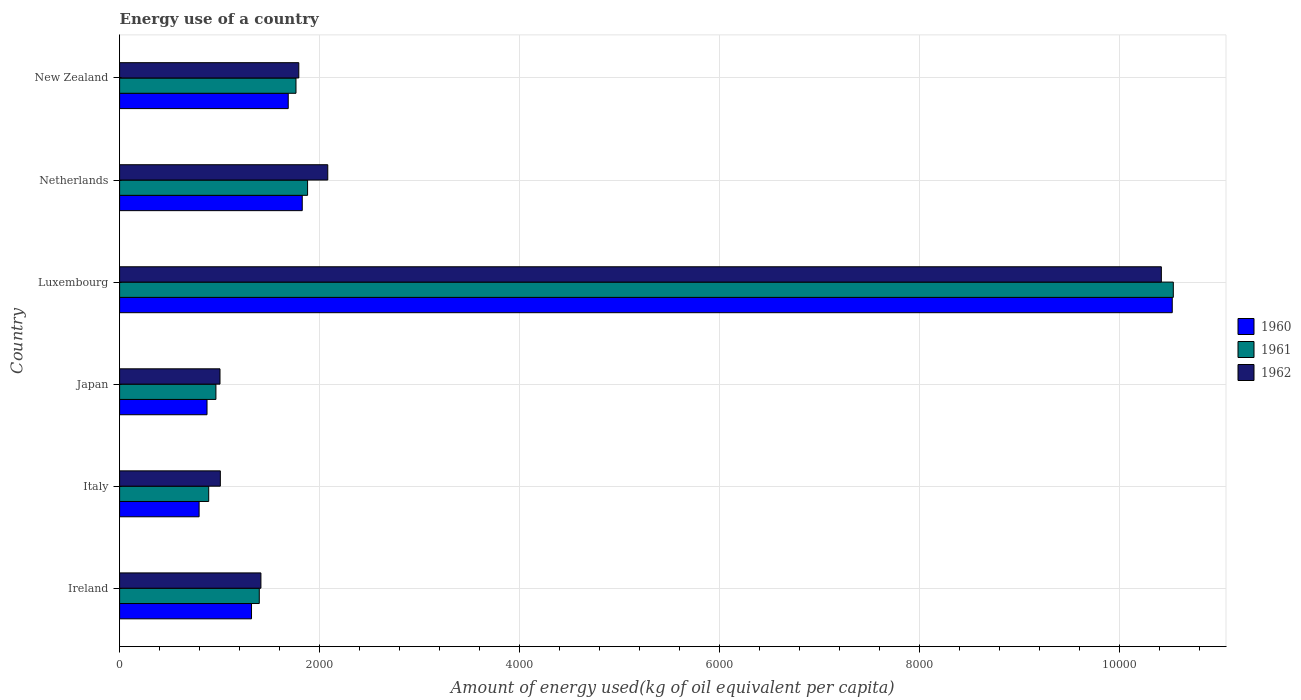Are the number of bars on each tick of the Y-axis equal?
Offer a very short reply. Yes. What is the label of the 3rd group of bars from the top?
Offer a terse response. Luxembourg. In how many cases, is the number of bars for a given country not equal to the number of legend labels?
Your answer should be compact. 0. What is the amount of energy used in in 1962 in Japan?
Keep it short and to the point. 1003.75. Across all countries, what is the maximum amount of energy used in in 1962?
Offer a very short reply. 1.04e+04. Across all countries, what is the minimum amount of energy used in in 1961?
Ensure brevity in your answer.  890.69. In which country was the amount of energy used in in 1960 maximum?
Make the answer very short. Luxembourg. What is the total amount of energy used in in 1961 in the graph?
Offer a terse response. 1.74e+04. What is the difference between the amount of energy used in in 1961 in Luxembourg and that in Netherlands?
Your answer should be very brief. 8654.87. What is the difference between the amount of energy used in in 1961 in Luxembourg and the amount of energy used in in 1960 in Japan?
Provide a succinct answer. 9660.11. What is the average amount of energy used in in 1960 per country?
Offer a terse response. 2837.11. What is the difference between the amount of energy used in in 1962 and amount of energy used in in 1961 in Ireland?
Your answer should be very brief. 16.26. What is the ratio of the amount of energy used in in 1960 in Ireland to that in New Zealand?
Ensure brevity in your answer.  0.78. Is the amount of energy used in in 1960 in Netherlands less than that in New Zealand?
Provide a short and direct response. No. Is the difference between the amount of energy used in in 1962 in Italy and Netherlands greater than the difference between the amount of energy used in in 1961 in Italy and Netherlands?
Offer a very short reply. No. What is the difference between the highest and the second highest amount of energy used in in 1960?
Offer a very short reply. 8697.47. What is the difference between the highest and the lowest amount of energy used in in 1961?
Your answer should be very brief. 9643.33. In how many countries, is the amount of energy used in in 1960 greater than the average amount of energy used in in 1960 taken over all countries?
Your answer should be very brief. 1. What does the 3rd bar from the top in Netherlands represents?
Keep it short and to the point. 1960. What does the 1st bar from the bottom in New Zealand represents?
Your answer should be compact. 1960. How many bars are there?
Give a very brief answer. 18. Are all the bars in the graph horizontal?
Provide a short and direct response. Yes. Are the values on the major ticks of X-axis written in scientific E-notation?
Your response must be concise. No. How many legend labels are there?
Provide a succinct answer. 3. What is the title of the graph?
Provide a short and direct response. Energy use of a country. What is the label or title of the X-axis?
Your answer should be very brief. Amount of energy used(kg of oil equivalent per capita). What is the label or title of the Y-axis?
Your answer should be very brief. Country. What is the Amount of energy used(kg of oil equivalent per capita) of 1960 in Ireland?
Provide a short and direct response. 1318.81. What is the Amount of energy used(kg of oil equivalent per capita) in 1961 in Ireland?
Your response must be concise. 1396.47. What is the Amount of energy used(kg of oil equivalent per capita) in 1962 in Ireland?
Ensure brevity in your answer.  1412.73. What is the Amount of energy used(kg of oil equivalent per capita) in 1960 in Italy?
Offer a very short reply. 794.82. What is the Amount of energy used(kg of oil equivalent per capita) in 1961 in Italy?
Offer a very short reply. 890.69. What is the Amount of energy used(kg of oil equivalent per capita) of 1962 in Italy?
Your answer should be compact. 1007.05. What is the Amount of energy used(kg of oil equivalent per capita) of 1960 in Japan?
Give a very brief answer. 873.91. What is the Amount of energy used(kg of oil equivalent per capita) of 1961 in Japan?
Provide a succinct answer. 962.91. What is the Amount of energy used(kg of oil equivalent per capita) in 1962 in Japan?
Make the answer very short. 1003.75. What is the Amount of energy used(kg of oil equivalent per capita) in 1960 in Luxembourg?
Your response must be concise. 1.05e+04. What is the Amount of energy used(kg of oil equivalent per capita) in 1961 in Luxembourg?
Give a very brief answer. 1.05e+04. What is the Amount of energy used(kg of oil equivalent per capita) of 1962 in Luxembourg?
Your response must be concise. 1.04e+04. What is the Amount of energy used(kg of oil equivalent per capita) of 1960 in Netherlands?
Give a very brief answer. 1825.93. What is the Amount of energy used(kg of oil equivalent per capita) in 1961 in Netherlands?
Offer a very short reply. 1879.15. What is the Amount of energy used(kg of oil equivalent per capita) in 1962 in Netherlands?
Give a very brief answer. 2081.01. What is the Amount of energy used(kg of oil equivalent per capita) in 1960 in New Zealand?
Make the answer very short. 1685.79. What is the Amount of energy used(kg of oil equivalent per capita) of 1961 in New Zealand?
Give a very brief answer. 1763.26. What is the Amount of energy used(kg of oil equivalent per capita) in 1962 in New Zealand?
Your answer should be very brief. 1791.46. Across all countries, what is the maximum Amount of energy used(kg of oil equivalent per capita) in 1960?
Ensure brevity in your answer.  1.05e+04. Across all countries, what is the maximum Amount of energy used(kg of oil equivalent per capita) in 1961?
Provide a short and direct response. 1.05e+04. Across all countries, what is the maximum Amount of energy used(kg of oil equivalent per capita) of 1962?
Provide a short and direct response. 1.04e+04. Across all countries, what is the minimum Amount of energy used(kg of oil equivalent per capita) in 1960?
Give a very brief answer. 794.82. Across all countries, what is the minimum Amount of energy used(kg of oil equivalent per capita) of 1961?
Your response must be concise. 890.69. Across all countries, what is the minimum Amount of energy used(kg of oil equivalent per capita) of 1962?
Make the answer very short. 1003.75. What is the total Amount of energy used(kg of oil equivalent per capita) of 1960 in the graph?
Give a very brief answer. 1.70e+04. What is the total Amount of energy used(kg of oil equivalent per capita) of 1961 in the graph?
Your response must be concise. 1.74e+04. What is the total Amount of energy used(kg of oil equivalent per capita) of 1962 in the graph?
Make the answer very short. 1.77e+04. What is the difference between the Amount of energy used(kg of oil equivalent per capita) of 1960 in Ireland and that in Italy?
Ensure brevity in your answer.  524. What is the difference between the Amount of energy used(kg of oil equivalent per capita) in 1961 in Ireland and that in Italy?
Offer a very short reply. 505.78. What is the difference between the Amount of energy used(kg of oil equivalent per capita) in 1962 in Ireland and that in Italy?
Keep it short and to the point. 405.68. What is the difference between the Amount of energy used(kg of oil equivalent per capita) of 1960 in Ireland and that in Japan?
Offer a very short reply. 444.9. What is the difference between the Amount of energy used(kg of oil equivalent per capita) of 1961 in Ireland and that in Japan?
Make the answer very short. 433.56. What is the difference between the Amount of energy used(kg of oil equivalent per capita) in 1962 in Ireland and that in Japan?
Your answer should be very brief. 408.98. What is the difference between the Amount of energy used(kg of oil equivalent per capita) in 1960 in Ireland and that in Luxembourg?
Offer a terse response. -9204.59. What is the difference between the Amount of energy used(kg of oil equivalent per capita) of 1961 in Ireland and that in Luxembourg?
Give a very brief answer. -9137.55. What is the difference between the Amount of energy used(kg of oil equivalent per capita) in 1962 in Ireland and that in Luxembourg?
Keep it short and to the point. -9001.81. What is the difference between the Amount of energy used(kg of oil equivalent per capita) of 1960 in Ireland and that in Netherlands?
Your response must be concise. -507.12. What is the difference between the Amount of energy used(kg of oil equivalent per capita) of 1961 in Ireland and that in Netherlands?
Offer a terse response. -482.68. What is the difference between the Amount of energy used(kg of oil equivalent per capita) in 1962 in Ireland and that in Netherlands?
Keep it short and to the point. -668.28. What is the difference between the Amount of energy used(kg of oil equivalent per capita) in 1960 in Ireland and that in New Zealand?
Offer a very short reply. -366.98. What is the difference between the Amount of energy used(kg of oil equivalent per capita) in 1961 in Ireland and that in New Zealand?
Provide a short and direct response. -366.79. What is the difference between the Amount of energy used(kg of oil equivalent per capita) of 1962 in Ireland and that in New Zealand?
Keep it short and to the point. -378.73. What is the difference between the Amount of energy used(kg of oil equivalent per capita) of 1960 in Italy and that in Japan?
Provide a short and direct response. -79.09. What is the difference between the Amount of energy used(kg of oil equivalent per capita) in 1961 in Italy and that in Japan?
Ensure brevity in your answer.  -72.22. What is the difference between the Amount of energy used(kg of oil equivalent per capita) of 1962 in Italy and that in Japan?
Your answer should be very brief. 3.3. What is the difference between the Amount of energy used(kg of oil equivalent per capita) in 1960 in Italy and that in Luxembourg?
Your answer should be compact. -9728.59. What is the difference between the Amount of energy used(kg of oil equivalent per capita) in 1961 in Italy and that in Luxembourg?
Make the answer very short. -9643.33. What is the difference between the Amount of energy used(kg of oil equivalent per capita) in 1962 in Italy and that in Luxembourg?
Offer a terse response. -9407.49. What is the difference between the Amount of energy used(kg of oil equivalent per capita) of 1960 in Italy and that in Netherlands?
Your answer should be very brief. -1031.12. What is the difference between the Amount of energy used(kg of oil equivalent per capita) of 1961 in Italy and that in Netherlands?
Offer a terse response. -988.46. What is the difference between the Amount of energy used(kg of oil equivalent per capita) in 1962 in Italy and that in Netherlands?
Provide a succinct answer. -1073.96. What is the difference between the Amount of energy used(kg of oil equivalent per capita) of 1960 in Italy and that in New Zealand?
Offer a very short reply. -890.97. What is the difference between the Amount of energy used(kg of oil equivalent per capita) in 1961 in Italy and that in New Zealand?
Offer a terse response. -872.57. What is the difference between the Amount of energy used(kg of oil equivalent per capita) of 1962 in Italy and that in New Zealand?
Offer a terse response. -784.41. What is the difference between the Amount of energy used(kg of oil equivalent per capita) of 1960 in Japan and that in Luxembourg?
Your answer should be very brief. -9649.5. What is the difference between the Amount of energy used(kg of oil equivalent per capita) of 1961 in Japan and that in Luxembourg?
Ensure brevity in your answer.  -9571.11. What is the difference between the Amount of energy used(kg of oil equivalent per capita) in 1962 in Japan and that in Luxembourg?
Keep it short and to the point. -9410.79. What is the difference between the Amount of energy used(kg of oil equivalent per capita) of 1960 in Japan and that in Netherlands?
Make the answer very short. -952.02. What is the difference between the Amount of energy used(kg of oil equivalent per capita) in 1961 in Japan and that in Netherlands?
Your response must be concise. -916.24. What is the difference between the Amount of energy used(kg of oil equivalent per capita) in 1962 in Japan and that in Netherlands?
Your answer should be very brief. -1077.26. What is the difference between the Amount of energy used(kg of oil equivalent per capita) of 1960 in Japan and that in New Zealand?
Offer a terse response. -811.88. What is the difference between the Amount of energy used(kg of oil equivalent per capita) in 1961 in Japan and that in New Zealand?
Provide a short and direct response. -800.35. What is the difference between the Amount of energy used(kg of oil equivalent per capita) of 1962 in Japan and that in New Zealand?
Offer a terse response. -787.71. What is the difference between the Amount of energy used(kg of oil equivalent per capita) of 1960 in Luxembourg and that in Netherlands?
Your response must be concise. 8697.47. What is the difference between the Amount of energy used(kg of oil equivalent per capita) in 1961 in Luxembourg and that in Netherlands?
Keep it short and to the point. 8654.87. What is the difference between the Amount of energy used(kg of oil equivalent per capita) of 1962 in Luxembourg and that in Netherlands?
Make the answer very short. 8333.53. What is the difference between the Amount of energy used(kg of oil equivalent per capita) of 1960 in Luxembourg and that in New Zealand?
Your answer should be very brief. 8837.62. What is the difference between the Amount of energy used(kg of oil equivalent per capita) in 1961 in Luxembourg and that in New Zealand?
Make the answer very short. 8770.76. What is the difference between the Amount of energy used(kg of oil equivalent per capita) in 1962 in Luxembourg and that in New Zealand?
Keep it short and to the point. 8623.08. What is the difference between the Amount of energy used(kg of oil equivalent per capita) of 1960 in Netherlands and that in New Zealand?
Your answer should be very brief. 140.15. What is the difference between the Amount of energy used(kg of oil equivalent per capita) in 1961 in Netherlands and that in New Zealand?
Offer a terse response. 115.89. What is the difference between the Amount of energy used(kg of oil equivalent per capita) of 1962 in Netherlands and that in New Zealand?
Offer a terse response. 289.55. What is the difference between the Amount of energy used(kg of oil equivalent per capita) in 1960 in Ireland and the Amount of energy used(kg of oil equivalent per capita) in 1961 in Italy?
Give a very brief answer. 428.12. What is the difference between the Amount of energy used(kg of oil equivalent per capita) of 1960 in Ireland and the Amount of energy used(kg of oil equivalent per capita) of 1962 in Italy?
Your response must be concise. 311.76. What is the difference between the Amount of energy used(kg of oil equivalent per capita) in 1961 in Ireland and the Amount of energy used(kg of oil equivalent per capita) in 1962 in Italy?
Your response must be concise. 389.42. What is the difference between the Amount of energy used(kg of oil equivalent per capita) in 1960 in Ireland and the Amount of energy used(kg of oil equivalent per capita) in 1961 in Japan?
Your answer should be compact. 355.91. What is the difference between the Amount of energy used(kg of oil equivalent per capita) in 1960 in Ireland and the Amount of energy used(kg of oil equivalent per capita) in 1962 in Japan?
Make the answer very short. 315.06. What is the difference between the Amount of energy used(kg of oil equivalent per capita) in 1961 in Ireland and the Amount of energy used(kg of oil equivalent per capita) in 1962 in Japan?
Offer a terse response. 392.71. What is the difference between the Amount of energy used(kg of oil equivalent per capita) of 1960 in Ireland and the Amount of energy used(kg of oil equivalent per capita) of 1961 in Luxembourg?
Make the answer very short. -9215.21. What is the difference between the Amount of energy used(kg of oil equivalent per capita) of 1960 in Ireland and the Amount of energy used(kg of oil equivalent per capita) of 1962 in Luxembourg?
Offer a very short reply. -9095.73. What is the difference between the Amount of energy used(kg of oil equivalent per capita) in 1961 in Ireland and the Amount of energy used(kg of oil equivalent per capita) in 1962 in Luxembourg?
Your answer should be very brief. -9018.07. What is the difference between the Amount of energy used(kg of oil equivalent per capita) of 1960 in Ireland and the Amount of energy used(kg of oil equivalent per capita) of 1961 in Netherlands?
Your answer should be compact. -560.34. What is the difference between the Amount of energy used(kg of oil equivalent per capita) in 1960 in Ireland and the Amount of energy used(kg of oil equivalent per capita) in 1962 in Netherlands?
Offer a very short reply. -762.2. What is the difference between the Amount of energy used(kg of oil equivalent per capita) in 1961 in Ireland and the Amount of energy used(kg of oil equivalent per capita) in 1962 in Netherlands?
Offer a very short reply. -684.55. What is the difference between the Amount of energy used(kg of oil equivalent per capita) of 1960 in Ireland and the Amount of energy used(kg of oil equivalent per capita) of 1961 in New Zealand?
Provide a short and direct response. -444.45. What is the difference between the Amount of energy used(kg of oil equivalent per capita) in 1960 in Ireland and the Amount of energy used(kg of oil equivalent per capita) in 1962 in New Zealand?
Your answer should be compact. -472.65. What is the difference between the Amount of energy used(kg of oil equivalent per capita) of 1961 in Ireland and the Amount of energy used(kg of oil equivalent per capita) of 1962 in New Zealand?
Give a very brief answer. -395. What is the difference between the Amount of energy used(kg of oil equivalent per capita) in 1960 in Italy and the Amount of energy used(kg of oil equivalent per capita) in 1961 in Japan?
Offer a very short reply. -168.09. What is the difference between the Amount of energy used(kg of oil equivalent per capita) in 1960 in Italy and the Amount of energy used(kg of oil equivalent per capita) in 1962 in Japan?
Make the answer very short. -208.94. What is the difference between the Amount of energy used(kg of oil equivalent per capita) in 1961 in Italy and the Amount of energy used(kg of oil equivalent per capita) in 1962 in Japan?
Your answer should be compact. -113.06. What is the difference between the Amount of energy used(kg of oil equivalent per capita) of 1960 in Italy and the Amount of energy used(kg of oil equivalent per capita) of 1961 in Luxembourg?
Ensure brevity in your answer.  -9739.2. What is the difference between the Amount of energy used(kg of oil equivalent per capita) of 1960 in Italy and the Amount of energy used(kg of oil equivalent per capita) of 1962 in Luxembourg?
Offer a terse response. -9619.72. What is the difference between the Amount of energy used(kg of oil equivalent per capita) of 1961 in Italy and the Amount of energy used(kg of oil equivalent per capita) of 1962 in Luxembourg?
Your answer should be compact. -9523.85. What is the difference between the Amount of energy used(kg of oil equivalent per capita) in 1960 in Italy and the Amount of energy used(kg of oil equivalent per capita) in 1961 in Netherlands?
Make the answer very short. -1084.33. What is the difference between the Amount of energy used(kg of oil equivalent per capita) in 1960 in Italy and the Amount of energy used(kg of oil equivalent per capita) in 1962 in Netherlands?
Provide a succinct answer. -1286.2. What is the difference between the Amount of energy used(kg of oil equivalent per capita) in 1961 in Italy and the Amount of energy used(kg of oil equivalent per capita) in 1962 in Netherlands?
Your answer should be very brief. -1190.32. What is the difference between the Amount of energy used(kg of oil equivalent per capita) of 1960 in Italy and the Amount of energy used(kg of oil equivalent per capita) of 1961 in New Zealand?
Make the answer very short. -968.44. What is the difference between the Amount of energy used(kg of oil equivalent per capita) in 1960 in Italy and the Amount of energy used(kg of oil equivalent per capita) in 1962 in New Zealand?
Offer a very short reply. -996.65. What is the difference between the Amount of energy used(kg of oil equivalent per capita) of 1961 in Italy and the Amount of energy used(kg of oil equivalent per capita) of 1962 in New Zealand?
Offer a terse response. -900.77. What is the difference between the Amount of energy used(kg of oil equivalent per capita) of 1960 in Japan and the Amount of energy used(kg of oil equivalent per capita) of 1961 in Luxembourg?
Your answer should be compact. -9660.11. What is the difference between the Amount of energy used(kg of oil equivalent per capita) in 1960 in Japan and the Amount of energy used(kg of oil equivalent per capita) in 1962 in Luxembourg?
Offer a terse response. -9540.63. What is the difference between the Amount of energy used(kg of oil equivalent per capita) in 1961 in Japan and the Amount of energy used(kg of oil equivalent per capita) in 1962 in Luxembourg?
Provide a succinct answer. -9451.63. What is the difference between the Amount of energy used(kg of oil equivalent per capita) in 1960 in Japan and the Amount of energy used(kg of oil equivalent per capita) in 1961 in Netherlands?
Your answer should be very brief. -1005.24. What is the difference between the Amount of energy used(kg of oil equivalent per capita) of 1960 in Japan and the Amount of energy used(kg of oil equivalent per capita) of 1962 in Netherlands?
Offer a very short reply. -1207.1. What is the difference between the Amount of energy used(kg of oil equivalent per capita) in 1961 in Japan and the Amount of energy used(kg of oil equivalent per capita) in 1962 in Netherlands?
Ensure brevity in your answer.  -1118.1. What is the difference between the Amount of energy used(kg of oil equivalent per capita) of 1960 in Japan and the Amount of energy used(kg of oil equivalent per capita) of 1961 in New Zealand?
Your answer should be very brief. -889.35. What is the difference between the Amount of energy used(kg of oil equivalent per capita) of 1960 in Japan and the Amount of energy used(kg of oil equivalent per capita) of 1962 in New Zealand?
Make the answer very short. -917.55. What is the difference between the Amount of energy used(kg of oil equivalent per capita) in 1961 in Japan and the Amount of energy used(kg of oil equivalent per capita) in 1962 in New Zealand?
Offer a very short reply. -828.55. What is the difference between the Amount of energy used(kg of oil equivalent per capita) in 1960 in Luxembourg and the Amount of energy used(kg of oil equivalent per capita) in 1961 in Netherlands?
Your response must be concise. 8644.26. What is the difference between the Amount of energy used(kg of oil equivalent per capita) in 1960 in Luxembourg and the Amount of energy used(kg of oil equivalent per capita) in 1962 in Netherlands?
Offer a very short reply. 8442.4. What is the difference between the Amount of energy used(kg of oil equivalent per capita) of 1961 in Luxembourg and the Amount of energy used(kg of oil equivalent per capita) of 1962 in Netherlands?
Keep it short and to the point. 8453.01. What is the difference between the Amount of energy used(kg of oil equivalent per capita) in 1960 in Luxembourg and the Amount of energy used(kg of oil equivalent per capita) in 1961 in New Zealand?
Make the answer very short. 8760.15. What is the difference between the Amount of energy used(kg of oil equivalent per capita) of 1960 in Luxembourg and the Amount of energy used(kg of oil equivalent per capita) of 1962 in New Zealand?
Ensure brevity in your answer.  8731.95. What is the difference between the Amount of energy used(kg of oil equivalent per capita) of 1961 in Luxembourg and the Amount of energy used(kg of oil equivalent per capita) of 1962 in New Zealand?
Offer a terse response. 8742.56. What is the difference between the Amount of energy used(kg of oil equivalent per capita) of 1960 in Netherlands and the Amount of energy used(kg of oil equivalent per capita) of 1961 in New Zealand?
Give a very brief answer. 62.67. What is the difference between the Amount of energy used(kg of oil equivalent per capita) of 1960 in Netherlands and the Amount of energy used(kg of oil equivalent per capita) of 1962 in New Zealand?
Your response must be concise. 34.47. What is the difference between the Amount of energy used(kg of oil equivalent per capita) in 1961 in Netherlands and the Amount of energy used(kg of oil equivalent per capita) in 1962 in New Zealand?
Your response must be concise. 87.69. What is the average Amount of energy used(kg of oil equivalent per capita) of 1960 per country?
Provide a short and direct response. 2837.11. What is the average Amount of energy used(kg of oil equivalent per capita) in 1961 per country?
Offer a terse response. 2904.41. What is the average Amount of energy used(kg of oil equivalent per capita) in 1962 per country?
Your response must be concise. 2951.76. What is the difference between the Amount of energy used(kg of oil equivalent per capita) of 1960 and Amount of energy used(kg of oil equivalent per capita) of 1961 in Ireland?
Keep it short and to the point. -77.65. What is the difference between the Amount of energy used(kg of oil equivalent per capita) in 1960 and Amount of energy used(kg of oil equivalent per capita) in 1962 in Ireland?
Ensure brevity in your answer.  -93.92. What is the difference between the Amount of energy used(kg of oil equivalent per capita) in 1961 and Amount of energy used(kg of oil equivalent per capita) in 1962 in Ireland?
Keep it short and to the point. -16.26. What is the difference between the Amount of energy used(kg of oil equivalent per capita) of 1960 and Amount of energy used(kg of oil equivalent per capita) of 1961 in Italy?
Keep it short and to the point. -95.87. What is the difference between the Amount of energy used(kg of oil equivalent per capita) of 1960 and Amount of energy used(kg of oil equivalent per capita) of 1962 in Italy?
Your response must be concise. -212.23. What is the difference between the Amount of energy used(kg of oil equivalent per capita) in 1961 and Amount of energy used(kg of oil equivalent per capita) in 1962 in Italy?
Your response must be concise. -116.36. What is the difference between the Amount of energy used(kg of oil equivalent per capita) of 1960 and Amount of energy used(kg of oil equivalent per capita) of 1961 in Japan?
Your answer should be very brief. -89. What is the difference between the Amount of energy used(kg of oil equivalent per capita) of 1960 and Amount of energy used(kg of oil equivalent per capita) of 1962 in Japan?
Provide a succinct answer. -129.84. What is the difference between the Amount of energy used(kg of oil equivalent per capita) of 1961 and Amount of energy used(kg of oil equivalent per capita) of 1962 in Japan?
Keep it short and to the point. -40.85. What is the difference between the Amount of energy used(kg of oil equivalent per capita) in 1960 and Amount of energy used(kg of oil equivalent per capita) in 1961 in Luxembourg?
Keep it short and to the point. -10.61. What is the difference between the Amount of energy used(kg of oil equivalent per capita) in 1960 and Amount of energy used(kg of oil equivalent per capita) in 1962 in Luxembourg?
Offer a very short reply. 108.87. What is the difference between the Amount of energy used(kg of oil equivalent per capita) in 1961 and Amount of energy used(kg of oil equivalent per capita) in 1962 in Luxembourg?
Your answer should be compact. 119.48. What is the difference between the Amount of energy used(kg of oil equivalent per capita) in 1960 and Amount of energy used(kg of oil equivalent per capita) in 1961 in Netherlands?
Your answer should be compact. -53.22. What is the difference between the Amount of energy used(kg of oil equivalent per capita) of 1960 and Amount of energy used(kg of oil equivalent per capita) of 1962 in Netherlands?
Your response must be concise. -255.08. What is the difference between the Amount of energy used(kg of oil equivalent per capita) in 1961 and Amount of energy used(kg of oil equivalent per capita) in 1962 in Netherlands?
Your answer should be compact. -201.86. What is the difference between the Amount of energy used(kg of oil equivalent per capita) of 1960 and Amount of energy used(kg of oil equivalent per capita) of 1961 in New Zealand?
Ensure brevity in your answer.  -77.47. What is the difference between the Amount of energy used(kg of oil equivalent per capita) in 1960 and Amount of energy used(kg of oil equivalent per capita) in 1962 in New Zealand?
Offer a terse response. -105.67. What is the difference between the Amount of energy used(kg of oil equivalent per capita) of 1961 and Amount of energy used(kg of oil equivalent per capita) of 1962 in New Zealand?
Keep it short and to the point. -28.2. What is the ratio of the Amount of energy used(kg of oil equivalent per capita) in 1960 in Ireland to that in Italy?
Give a very brief answer. 1.66. What is the ratio of the Amount of energy used(kg of oil equivalent per capita) of 1961 in Ireland to that in Italy?
Offer a terse response. 1.57. What is the ratio of the Amount of energy used(kg of oil equivalent per capita) in 1962 in Ireland to that in Italy?
Offer a very short reply. 1.4. What is the ratio of the Amount of energy used(kg of oil equivalent per capita) of 1960 in Ireland to that in Japan?
Your answer should be very brief. 1.51. What is the ratio of the Amount of energy used(kg of oil equivalent per capita) in 1961 in Ireland to that in Japan?
Keep it short and to the point. 1.45. What is the ratio of the Amount of energy used(kg of oil equivalent per capita) of 1962 in Ireland to that in Japan?
Ensure brevity in your answer.  1.41. What is the ratio of the Amount of energy used(kg of oil equivalent per capita) in 1960 in Ireland to that in Luxembourg?
Provide a succinct answer. 0.13. What is the ratio of the Amount of energy used(kg of oil equivalent per capita) of 1961 in Ireland to that in Luxembourg?
Make the answer very short. 0.13. What is the ratio of the Amount of energy used(kg of oil equivalent per capita) of 1962 in Ireland to that in Luxembourg?
Ensure brevity in your answer.  0.14. What is the ratio of the Amount of energy used(kg of oil equivalent per capita) in 1960 in Ireland to that in Netherlands?
Offer a very short reply. 0.72. What is the ratio of the Amount of energy used(kg of oil equivalent per capita) in 1961 in Ireland to that in Netherlands?
Offer a very short reply. 0.74. What is the ratio of the Amount of energy used(kg of oil equivalent per capita) in 1962 in Ireland to that in Netherlands?
Provide a succinct answer. 0.68. What is the ratio of the Amount of energy used(kg of oil equivalent per capita) in 1960 in Ireland to that in New Zealand?
Provide a succinct answer. 0.78. What is the ratio of the Amount of energy used(kg of oil equivalent per capita) in 1961 in Ireland to that in New Zealand?
Keep it short and to the point. 0.79. What is the ratio of the Amount of energy used(kg of oil equivalent per capita) of 1962 in Ireland to that in New Zealand?
Make the answer very short. 0.79. What is the ratio of the Amount of energy used(kg of oil equivalent per capita) in 1960 in Italy to that in Japan?
Provide a succinct answer. 0.91. What is the ratio of the Amount of energy used(kg of oil equivalent per capita) in 1961 in Italy to that in Japan?
Ensure brevity in your answer.  0.93. What is the ratio of the Amount of energy used(kg of oil equivalent per capita) of 1960 in Italy to that in Luxembourg?
Your response must be concise. 0.08. What is the ratio of the Amount of energy used(kg of oil equivalent per capita) in 1961 in Italy to that in Luxembourg?
Provide a short and direct response. 0.08. What is the ratio of the Amount of energy used(kg of oil equivalent per capita) of 1962 in Italy to that in Luxembourg?
Your answer should be very brief. 0.1. What is the ratio of the Amount of energy used(kg of oil equivalent per capita) in 1960 in Italy to that in Netherlands?
Make the answer very short. 0.44. What is the ratio of the Amount of energy used(kg of oil equivalent per capita) in 1961 in Italy to that in Netherlands?
Provide a short and direct response. 0.47. What is the ratio of the Amount of energy used(kg of oil equivalent per capita) in 1962 in Italy to that in Netherlands?
Keep it short and to the point. 0.48. What is the ratio of the Amount of energy used(kg of oil equivalent per capita) of 1960 in Italy to that in New Zealand?
Ensure brevity in your answer.  0.47. What is the ratio of the Amount of energy used(kg of oil equivalent per capita) in 1961 in Italy to that in New Zealand?
Your answer should be compact. 0.51. What is the ratio of the Amount of energy used(kg of oil equivalent per capita) in 1962 in Italy to that in New Zealand?
Your answer should be very brief. 0.56. What is the ratio of the Amount of energy used(kg of oil equivalent per capita) of 1960 in Japan to that in Luxembourg?
Offer a very short reply. 0.08. What is the ratio of the Amount of energy used(kg of oil equivalent per capita) of 1961 in Japan to that in Luxembourg?
Your answer should be compact. 0.09. What is the ratio of the Amount of energy used(kg of oil equivalent per capita) in 1962 in Japan to that in Luxembourg?
Offer a very short reply. 0.1. What is the ratio of the Amount of energy used(kg of oil equivalent per capita) of 1960 in Japan to that in Netherlands?
Make the answer very short. 0.48. What is the ratio of the Amount of energy used(kg of oil equivalent per capita) in 1961 in Japan to that in Netherlands?
Make the answer very short. 0.51. What is the ratio of the Amount of energy used(kg of oil equivalent per capita) in 1962 in Japan to that in Netherlands?
Offer a very short reply. 0.48. What is the ratio of the Amount of energy used(kg of oil equivalent per capita) of 1960 in Japan to that in New Zealand?
Your answer should be very brief. 0.52. What is the ratio of the Amount of energy used(kg of oil equivalent per capita) in 1961 in Japan to that in New Zealand?
Your answer should be compact. 0.55. What is the ratio of the Amount of energy used(kg of oil equivalent per capita) of 1962 in Japan to that in New Zealand?
Offer a terse response. 0.56. What is the ratio of the Amount of energy used(kg of oil equivalent per capita) of 1960 in Luxembourg to that in Netherlands?
Ensure brevity in your answer.  5.76. What is the ratio of the Amount of energy used(kg of oil equivalent per capita) in 1961 in Luxembourg to that in Netherlands?
Your answer should be very brief. 5.61. What is the ratio of the Amount of energy used(kg of oil equivalent per capita) of 1962 in Luxembourg to that in Netherlands?
Offer a terse response. 5. What is the ratio of the Amount of energy used(kg of oil equivalent per capita) in 1960 in Luxembourg to that in New Zealand?
Provide a short and direct response. 6.24. What is the ratio of the Amount of energy used(kg of oil equivalent per capita) in 1961 in Luxembourg to that in New Zealand?
Your answer should be compact. 5.97. What is the ratio of the Amount of energy used(kg of oil equivalent per capita) of 1962 in Luxembourg to that in New Zealand?
Make the answer very short. 5.81. What is the ratio of the Amount of energy used(kg of oil equivalent per capita) of 1960 in Netherlands to that in New Zealand?
Ensure brevity in your answer.  1.08. What is the ratio of the Amount of energy used(kg of oil equivalent per capita) in 1961 in Netherlands to that in New Zealand?
Keep it short and to the point. 1.07. What is the ratio of the Amount of energy used(kg of oil equivalent per capita) of 1962 in Netherlands to that in New Zealand?
Your response must be concise. 1.16. What is the difference between the highest and the second highest Amount of energy used(kg of oil equivalent per capita) in 1960?
Offer a very short reply. 8697.47. What is the difference between the highest and the second highest Amount of energy used(kg of oil equivalent per capita) in 1961?
Provide a succinct answer. 8654.87. What is the difference between the highest and the second highest Amount of energy used(kg of oil equivalent per capita) of 1962?
Ensure brevity in your answer.  8333.53. What is the difference between the highest and the lowest Amount of energy used(kg of oil equivalent per capita) of 1960?
Ensure brevity in your answer.  9728.59. What is the difference between the highest and the lowest Amount of energy used(kg of oil equivalent per capita) of 1961?
Make the answer very short. 9643.33. What is the difference between the highest and the lowest Amount of energy used(kg of oil equivalent per capita) in 1962?
Ensure brevity in your answer.  9410.79. 